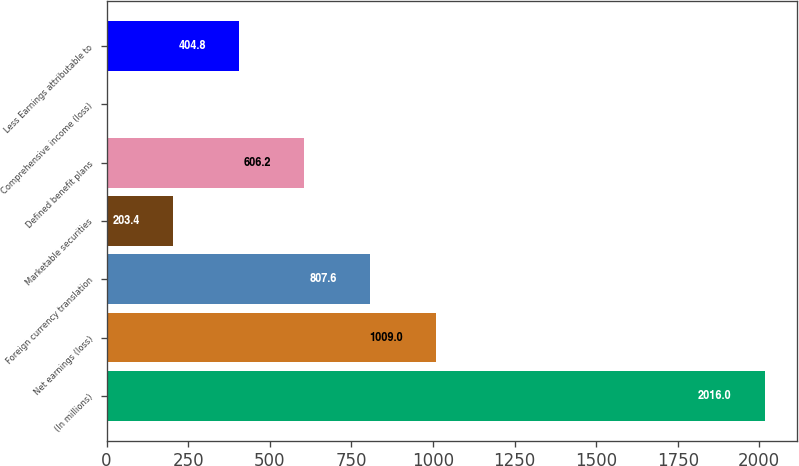<chart> <loc_0><loc_0><loc_500><loc_500><bar_chart><fcel>(In millions)<fcel>Net earnings (loss)<fcel>Foreign currency translation<fcel>Marketable securities<fcel>Defined benefit plans<fcel>Comprehensive income (loss)<fcel>Less Earnings attributable to<nl><fcel>2016<fcel>1009<fcel>807.6<fcel>203.4<fcel>606.2<fcel>2<fcel>404.8<nl></chart> 